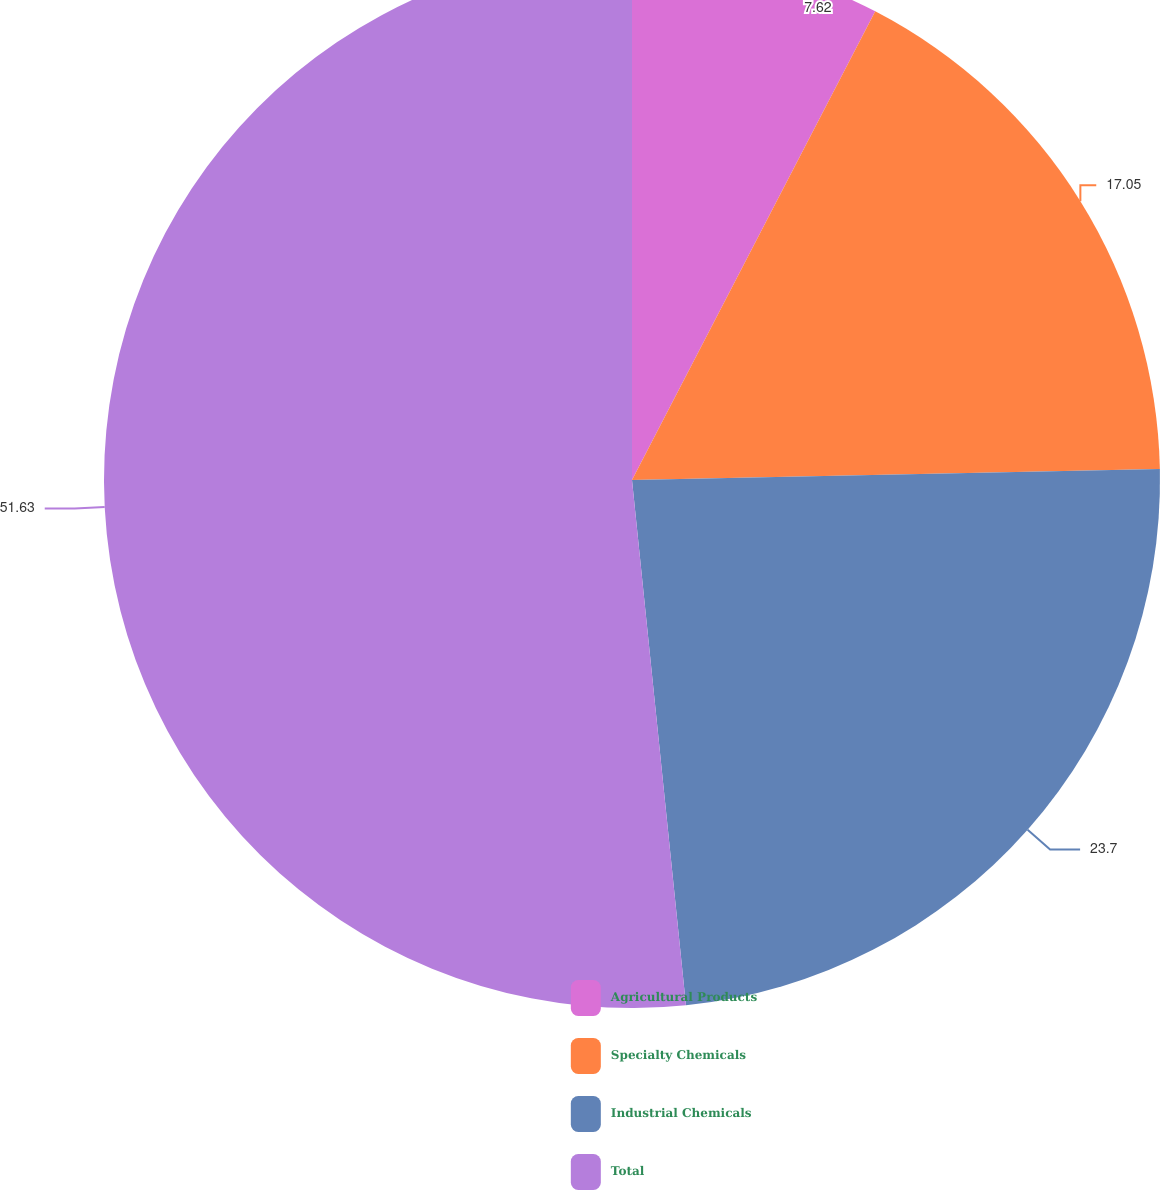Convert chart to OTSL. <chart><loc_0><loc_0><loc_500><loc_500><pie_chart><fcel>Agricultural Products<fcel>Specialty Chemicals<fcel>Industrial Chemicals<fcel>Total<nl><fcel>7.62%<fcel>17.05%<fcel>23.7%<fcel>51.63%<nl></chart> 